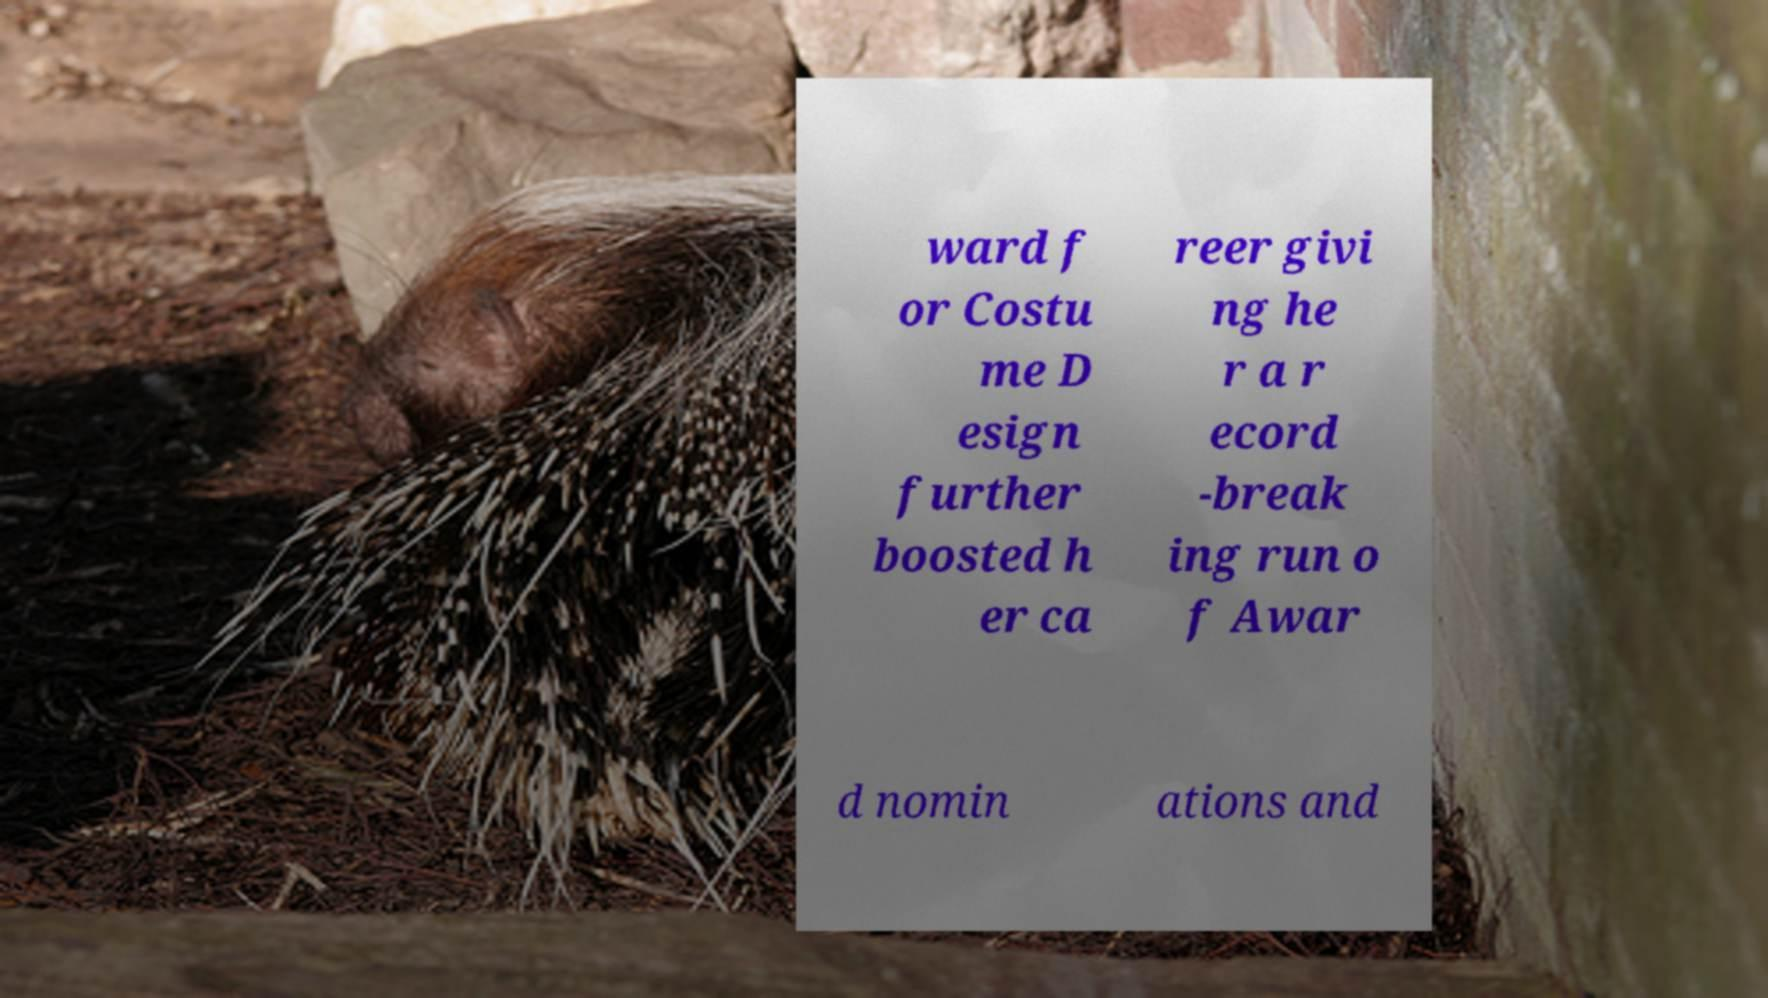There's text embedded in this image that I need extracted. Can you transcribe it verbatim? ward f or Costu me D esign further boosted h er ca reer givi ng he r a r ecord -break ing run o f Awar d nomin ations and 